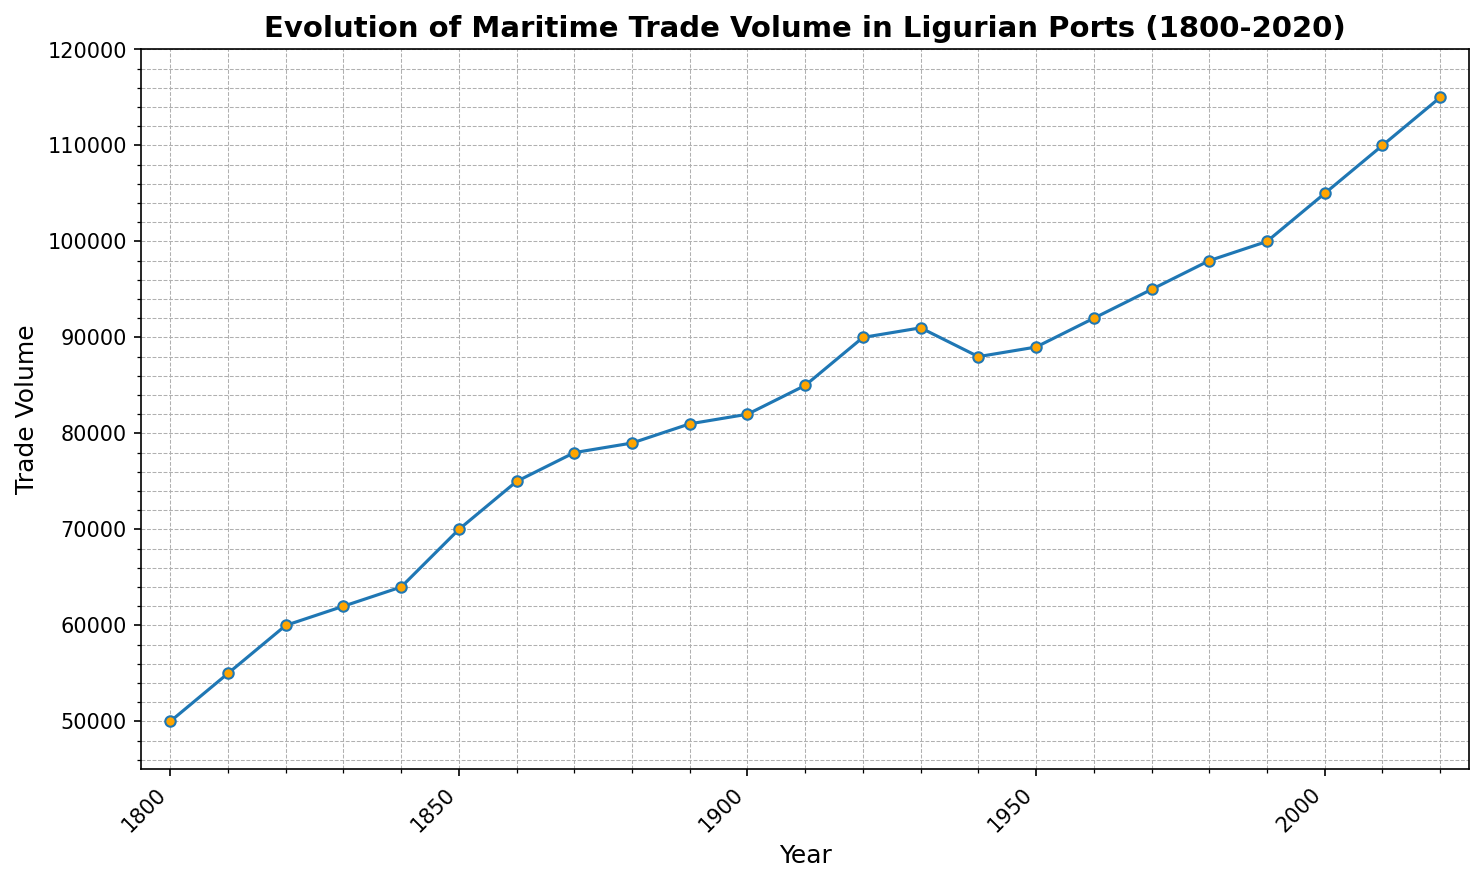What is the overall trend in maritime trade volume from 1800 to 2020? The line chart shows a general upward trend in maritime trade volume from 1800 to 2020, with several small dips and consistent growth over the long term.
Answer: Upward trend How much did maritime trade volume increase between 1800 and 1900? To find the increase, subtract the trade volume in 1800 from 1900. Trade volume in 1900 is 82,000, and in 1800 it is 50,000. Therefore, the increase is 82,000 - 50,000 = 32,000.
Answer: 32,000 Which decade saw the steepest increase in trade volume? By examining the slopes of the lines between the data points, the steepest increase can be identified. The decade with the steepest slope appears to be from 2000 to 2010, where the trade volume increased from 105,000 to 110,000, a difference of 5,000.
Answer: 2000-2010 How did the maritime trade volume change between 1930 and 1950? The trade volume in 1930 was 91,000, in 1940 it dipped to 88,000, and by 1950 it slightly recovered to 89,000. So, the general pattern is a dip and then a slight recovery.
Answer: Dip and slight recovery Which year had significant dips in trade volume, and what is the difference from the preceding year? Significant dips can be noted in 1940 compared to 1930. Trade volume in 1930 was 91,000, and in 1940 it dipped to 88,000. The difference is 91,000 - 88,000 = 3,000.
Answer: 1940, 3,000 What was the maritime trade volume in 2000? From the plot, the trade volume in the year 2000 can be directly read as 105,000.
Answer: 105,000 What was the average trade volume between 1950 and 2000? The trade volumes for the years 1950, 1960, 1970, 1980, 1990, and 2000 are: 89,000, 92,000, 95,000, 98,000, 100,000, and 105,000 respectively. The average is (89,000 + 92,000 + 95,000 + 98,000 + 100,000 + 105,000) / 6 = 579,000 / 6 = 96,500.
Answer: 96,500 During what period did maritime trade volume first exceed 100,000? From the plot, maritime trade volume first exceeds 100,000 between 1990 and 2000.
Answer: 1990-2000 What was the percentage increase in trade volume from 1980 to 2020? Trade volume in 1980 was 98,000 and in 2020 it was 115,000. To find the percentage increase, use the formula [(Final - Initial) / Initial] * 100. So, [(115,000 - 98,000) / 98,000] * 100 = 17.35%.
Answer: 17.35% How does the trade volume of 2020 compare visually to the trade volume of 1800? The trade volume in 2020 is significantly higher compared to 1800, as the line in 2020 is at the top end of the y-axis range over 100,000, while in 1800 it is close to the bottom around 50,000.
Answer: Significantly higher 